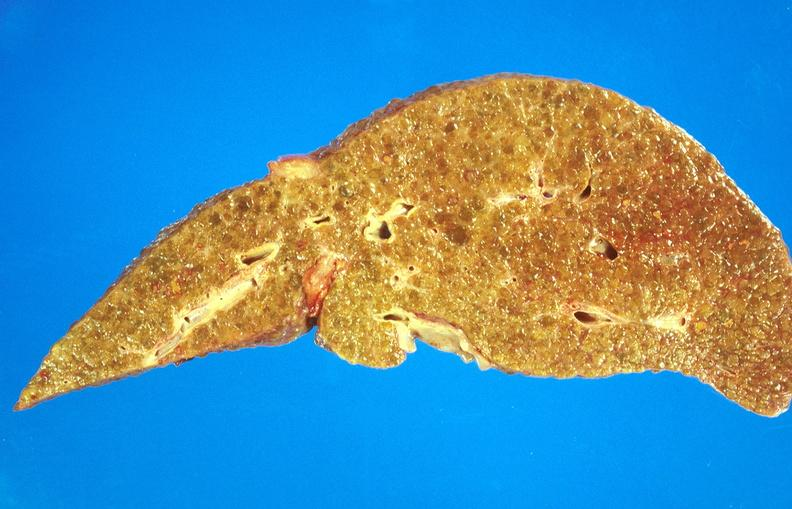what is present?
Answer the question using a single word or phrase. Hepatobiliary 